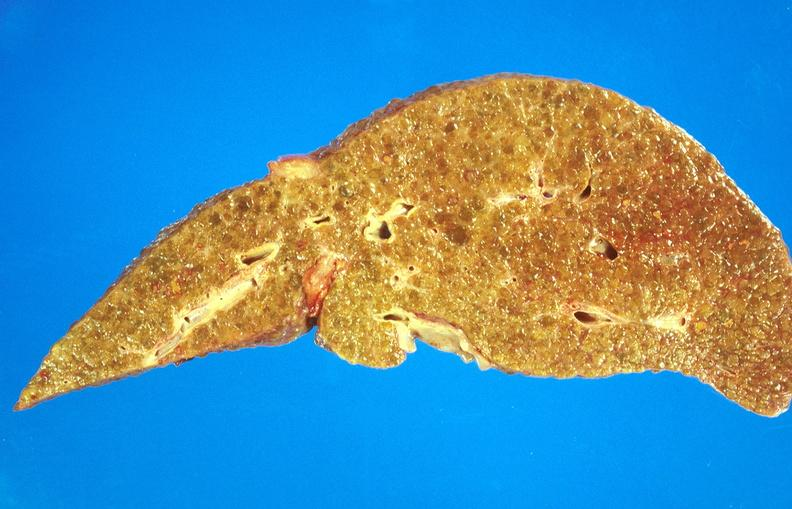what is present?
Answer the question using a single word or phrase. Hepatobiliary 